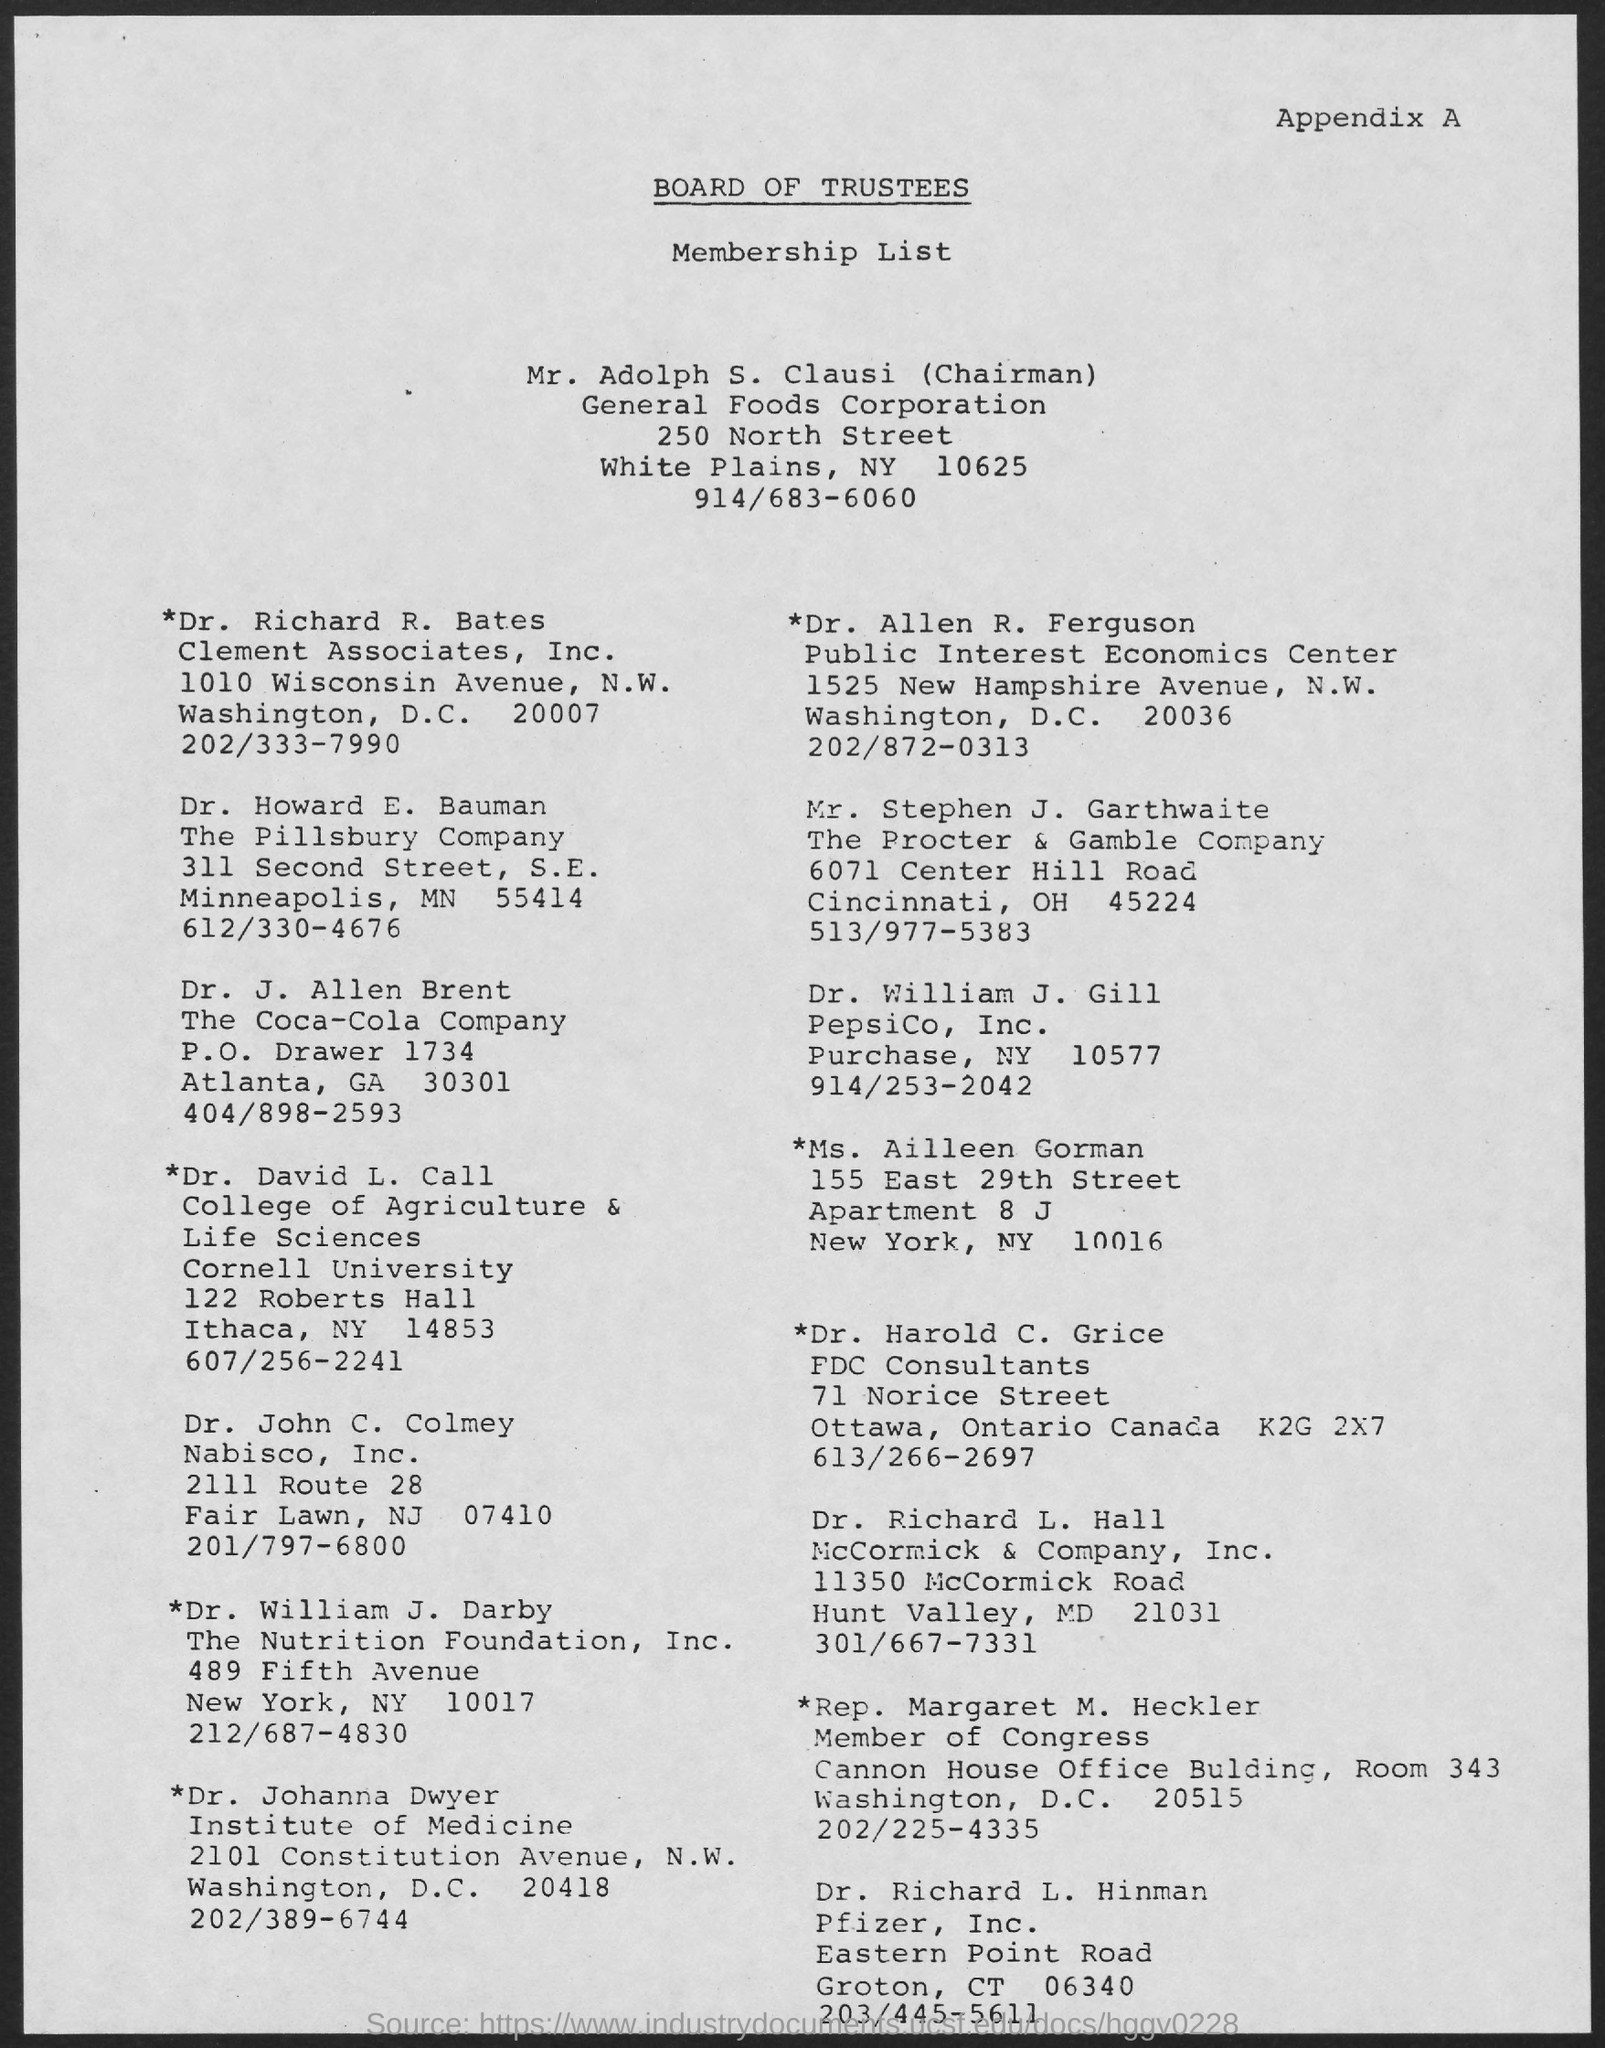Mention a couple of crucial points in this snapshot. What is the title of the document? It is called the Board of Trustees... The Chairman is Mr. Adolph S. Clausi. 